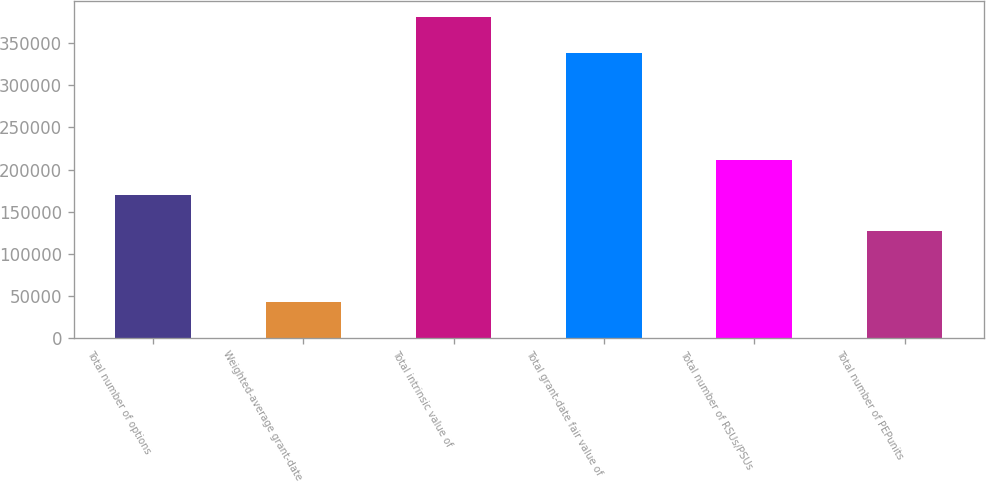<chart> <loc_0><loc_0><loc_500><loc_500><bar_chart><fcel>Total number of options<fcel>Weighted-average grant-date<fcel>Total intrinsic value of<fcel>Total grant-date fair value of<fcel>Total number of RSUs/PSUs<fcel>Total number of PEPunits<nl><fcel>169306<fcel>42333<fcel>380927<fcel>338603<fcel>211630<fcel>126981<nl></chart> 